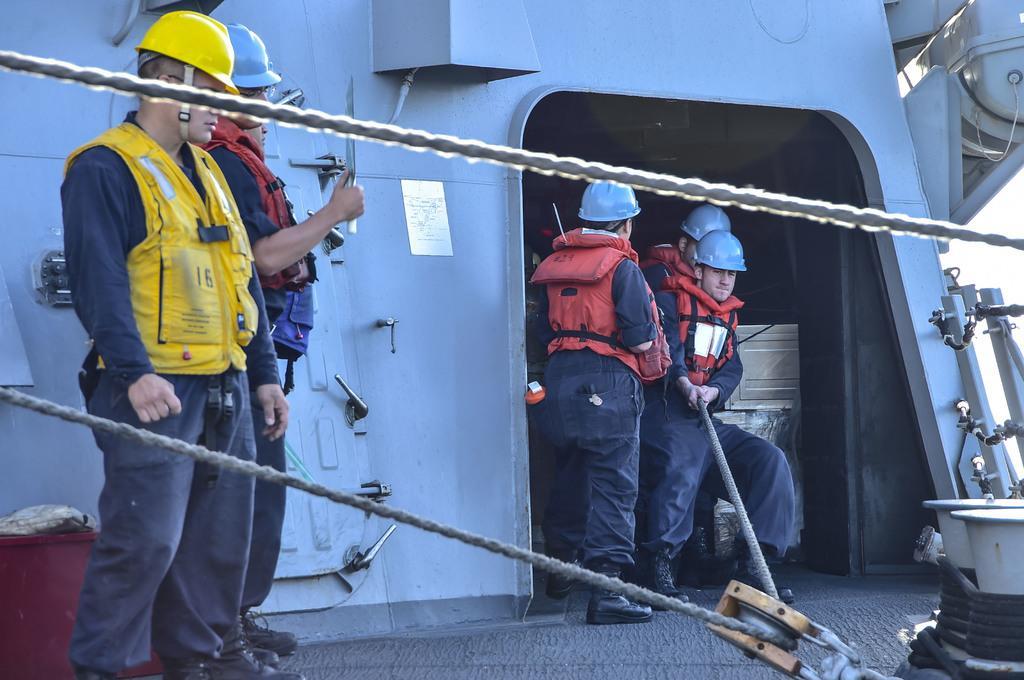Please provide a concise description of this image. In this image we can see some person wearing jackets, helmets standing, in the background of the image there are some persons pulling rope with their hands and we can see some objects. 